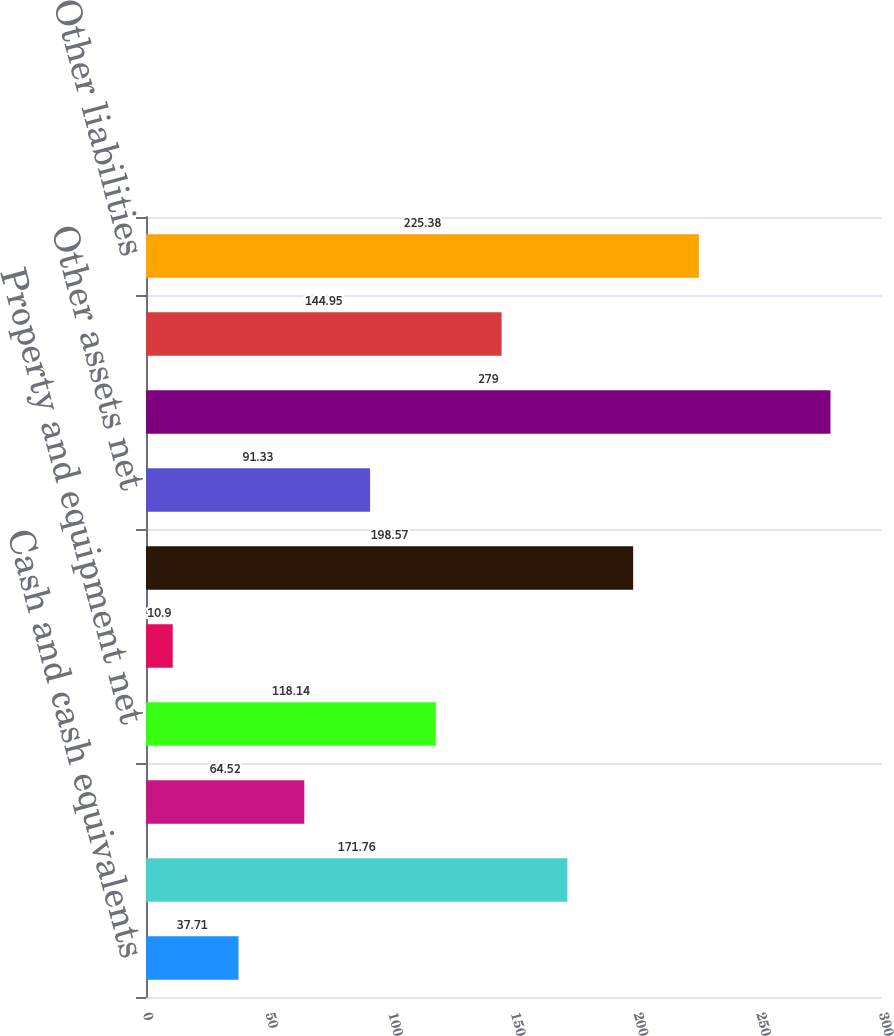Convert chart to OTSL. <chart><loc_0><loc_0><loc_500><loc_500><bar_chart><fcel>Cash and cash equivalents<fcel>Receivables net<fcel>Inventories<fcel>Property and equipment net<fcel>Goodwill<fcel>Intangible assets net<fcel>Other assets net<fcel>Assets held for sale<fcel>Accounts payable<fcel>Other liabilities<nl><fcel>37.71<fcel>171.76<fcel>64.52<fcel>118.14<fcel>10.9<fcel>198.57<fcel>91.33<fcel>279<fcel>144.95<fcel>225.38<nl></chart> 